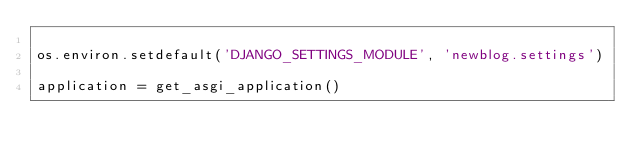Convert code to text. <code><loc_0><loc_0><loc_500><loc_500><_Python_>
os.environ.setdefault('DJANGO_SETTINGS_MODULE', 'newblog.settings')

application = get_asgi_application()
</code> 